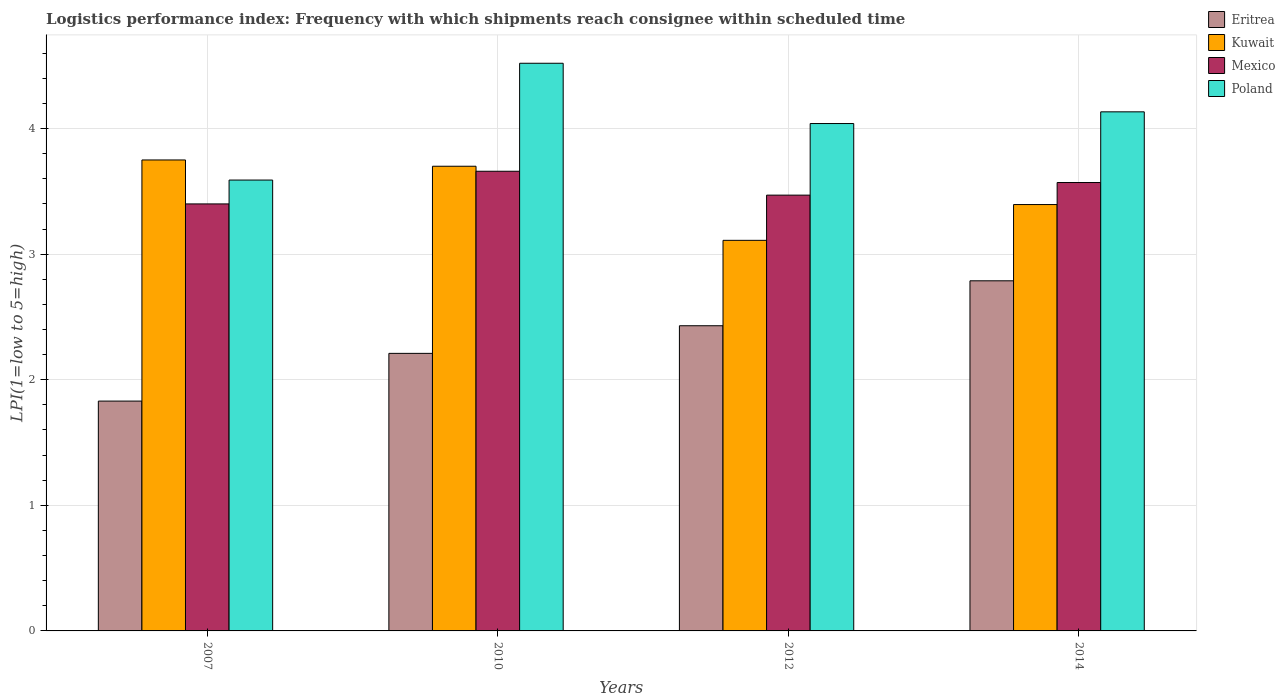Are the number of bars per tick equal to the number of legend labels?
Give a very brief answer. Yes. Are the number of bars on each tick of the X-axis equal?
Ensure brevity in your answer.  Yes. How many bars are there on the 1st tick from the right?
Offer a terse response. 4. What is the label of the 1st group of bars from the left?
Keep it short and to the point. 2007. What is the logistics performance index in Eritrea in 2014?
Your answer should be compact. 2.79. Across all years, what is the maximum logistics performance index in Eritrea?
Provide a short and direct response. 2.79. Across all years, what is the minimum logistics performance index in Kuwait?
Your response must be concise. 3.11. In which year was the logistics performance index in Poland maximum?
Your answer should be compact. 2010. In which year was the logistics performance index in Poland minimum?
Provide a succinct answer. 2007. What is the total logistics performance index in Eritrea in the graph?
Your answer should be very brief. 9.26. What is the difference between the logistics performance index in Eritrea in 2010 and that in 2012?
Ensure brevity in your answer.  -0.22. What is the difference between the logistics performance index in Mexico in 2010 and the logistics performance index in Eritrea in 2012?
Offer a terse response. 1.23. What is the average logistics performance index in Mexico per year?
Provide a short and direct response. 3.53. In the year 2007, what is the difference between the logistics performance index in Poland and logistics performance index in Kuwait?
Your answer should be very brief. -0.16. In how many years, is the logistics performance index in Poland greater than 2?
Offer a very short reply. 4. What is the ratio of the logistics performance index in Eritrea in 2007 to that in 2010?
Provide a succinct answer. 0.83. Is the logistics performance index in Kuwait in 2007 less than that in 2014?
Provide a short and direct response. No. Is the difference between the logistics performance index in Poland in 2007 and 2014 greater than the difference between the logistics performance index in Kuwait in 2007 and 2014?
Make the answer very short. No. What is the difference between the highest and the second highest logistics performance index in Poland?
Give a very brief answer. 0.39. What is the difference between the highest and the lowest logistics performance index in Kuwait?
Provide a succinct answer. 0.64. In how many years, is the logistics performance index in Eritrea greater than the average logistics performance index in Eritrea taken over all years?
Give a very brief answer. 2. Is the sum of the logistics performance index in Mexico in 2007 and 2014 greater than the maximum logistics performance index in Eritrea across all years?
Provide a short and direct response. Yes. Is it the case that in every year, the sum of the logistics performance index in Poland and logistics performance index in Eritrea is greater than the sum of logistics performance index in Mexico and logistics performance index in Kuwait?
Your answer should be very brief. No. What does the 4th bar from the right in 2012 represents?
Make the answer very short. Eritrea. How many bars are there?
Provide a short and direct response. 16. What is the difference between two consecutive major ticks on the Y-axis?
Keep it short and to the point. 1. Are the values on the major ticks of Y-axis written in scientific E-notation?
Give a very brief answer. No. Where does the legend appear in the graph?
Make the answer very short. Top right. How many legend labels are there?
Your answer should be compact. 4. What is the title of the graph?
Offer a terse response. Logistics performance index: Frequency with which shipments reach consignee within scheduled time. Does "Philippines" appear as one of the legend labels in the graph?
Ensure brevity in your answer.  No. What is the label or title of the X-axis?
Your response must be concise. Years. What is the label or title of the Y-axis?
Your answer should be compact. LPI(1=low to 5=high). What is the LPI(1=low to 5=high) of Eritrea in 2007?
Your answer should be compact. 1.83. What is the LPI(1=low to 5=high) in Kuwait in 2007?
Your answer should be very brief. 3.75. What is the LPI(1=low to 5=high) of Poland in 2007?
Your answer should be compact. 3.59. What is the LPI(1=low to 5=high) of Eritrea in 2010?
Your response must be concise. 2.21. What is the LPI(1=low to 5=high) in Mexico in 2010?
Provide a succinct answer. 3.66. What is the LPI(1=low to 5=high) of Poland in 2010?
Ensure brevity in your answer.  4.52. What is the LPI(1=low to 5=high) in Eritrea in 2012?
Make the answer very short. 2.43. What is the LPI(1=low to 5=high) of Kuwait in 2012?
Your answer should be very brief. 3.11. What is the LPI(1=low to 5=high) in Mexico in 2012?
Make the answer very short. 3.47. What is the LPI(1=low to 5=high) in Poland in 2012?
Offer a terse response. 4.04. What is the LPI(1=low to 5=high) in Eritrea in 2014?
Keep it short and to the point. 2.79. What is the LPI(1=low to 5=high) in Kuwait in 2014?
Keep it short and to the point. 3.39. What is the LPI(1=low to 5=high) in Mexico in 2014?
Offer a very short reply. 3.57. What is the LPI(1=low to 5=high) in Poland in 2014?
Your response must be concise. 4.13. Across all years, what is the maximum LPI(1=low to 5=high) of Eritrea?
Your answer should be compact. 2.79. Across all years, what is the maximum LPI(1=low to 5=high) of Kuwait?
Give a very brief answer. 3.75. Across all years, what is the maximum LPI(1=low to 5=high) in Mexico?
Offer a very short reply. 3.66. Across all years, what is the maximum LPI(1=low to 5=high) of Poland?
Provide a succinct answer. 4.52. Across all years, what is the minimum LPI(1=low to 5=high) in Eritrea?
Give a very brief answer. 1.83. Across all years, what is the minimum LPI(1=low to 5=high) in Kuwait?
Keep it short and to the point. 3.11. Across all years, what is the minimum LPI(1=low to 5=high) in Poland?
Offer a very short reply. 3.59. What is the total LPI(1=low to 5=high) in Eritrea in the graph?
Offer a very short reply. 9.26. What is the total LPI(1=low to 5=high) in Kuwait in the graph?
Give a very brief answer. 13.96. What is the total LPI(1=low to 5=high) in Mexico in the graph?
Ensure brevity in your answer.  14.1. What is the total LPI(1=low to 5=high) of Poland in the graph?
Provide a succinct answer. 16.28. What is the difference between the LPI(1=low to 5=high) of Eritrea in 2007 and that in 2010?
Provide a short and direct response. -0.38. What is the difference between the LPI(1=low to 5=high) in Kuwait in 2007 and that in 2010?
Your response must be concise. 0.05. What is the difference between the LPI(1=low to 5=high) of Mexico in 2007 and that in 2010?
Make the answer very short. -0.26. What is the difference between the LPI(1=low to 5=high) in Poland in 2007 and that in 2010?
Your response must be concise. -0.93. What is the difference between the LPI(1=low to 5=high) of Eritrea in 2007 and that in 2012?
Keep it short and to the point. -0.6. What is the difference between the LPI(1=low to 5=high) of Kuwait in 2007 and that in 2012?
Your response must be concise. 0.64. What is the difference between the LPI(1=low to 5=high) in Mexico in 2007 and that in 2012?
Make the answer very short. -0.07. What is the difference between the LPI(1=low to 5=high) in Poland in 2007 and that in 2012?
Ensure brevity in your answer.  -0.45. What is the difference between the LPI(1=low to 5=high) in Eritrea in 2007 and that in 2014?
Give a very brief answer. -0.96. What is the difference between the LPI(1=low to 5=high) of Kuwait in 2007 and that in 2014?
Your answer should be compact. 0.35. What is the difference between the LPI(1=low to 5=high) in Mexico in 2007 and that in 2014?
Provide a short and direct response. -0.17. What is the difference between the LPI(1=low to 5=high) of Poland in 2007 and that in 2014?
Your answer should be compact. -0.54. What is the difference between the LPI(1=low to 5=high) of Eritrea in 2010 and that in 2012?
Provide a succinct answer. -0.22. What is the difference between the LPI(1=low to 5=high) in Kuwait in 2010 and that in 2012?
Keep it short and to the point. 0.59. What is the difference between the LPI(1=low to 5=high) of Mexico in 2010 and that in 2012?
Offer a terse response. 0.19. What is the difference between the LPI(1=low to 5=high) in Poland in 2010 and that in 2012?
Ensure brevity in your answer.  0.48. What is the difference between the LPI(1=low to 5=high) in Eritrea in 2010 and that in 2014?
Provide a short and direct response. -0.58. What is the difference between the LPI(1=low to 5=high) in Kuwait in 2010 and that in 2014?
Offer a very short reply. 0.3. What is the difference between the LPI(1=low to 5=high) in Mexico in 2010 and that in 2014?
Offer a terse response. 0.09. What is the difference between the LPI(1=low to 5=high) in Poland in 2010 and that in 2014?
Provide a succinct answer. 0.39. What is the difference between the LPI(1=low to 5=high) of Eritrea in 2012 and that in 2014?
Your response must be concise. -0.36. What is the difference between the LPI(1=low to 5=high) in Kuwait in 2012 and that in 2014?
Keep it short and to the point. -0.28. What is the difference between the LPI(1=low to 5=high) of Mexico in 2012 and that in 2014?
Offer a very short reply. -0.1. What is the difference between the LPI(1=low to 5=high) of Poland in 2012 and that in 2014?
Give a very brief answer. -0.09. What is the difference between the LPI(1=low to 5=high) of Eritrea in 2007 and the LPI(1=low to 5=high) of Kuwait in 2010?
Your answer should be compact. -1.87. What is the difference between the LPI(1=low to 5=high) in Eritrea in 2007 and the LPI(1=low to 5=high) in Mexico in 2010?
Your answer should be very brief. -1.83. What is the difference between the LPI(1=low to 5=high) in Eritrea in 2007 and the LPI(1=low to 5=high) in Poland in 2010?
Give a very brief answer. -2.69. What is the difference between the LPI(1=low to 5=high) of Kuwait in 2007 and the LPI(1=low to 5=high) of Mexico in 2010?
Your answer should be compact. 0.09. What is the difference between the LPI(1=low to 5=high) in Kuwait in 2007 and the LPI(1=low to 5=high) in Poland in 2010?
Your answer should be compact. -0.77. What is the difference between the LPI(1=low to 5=high) of Mexico in 2007 and the LPI(1=low to 5=high) of Poland in 2010?
Provide a succinct answer. -1.12. What is the difference between the LPI(1=low to 5=high) in Eritrea in 2007 and the LPI(1=low to 5=high) in Kuwait in 2012?
Your answer should be compact. -1.28. What is the difference between the LPI(1=low to 5=high) of Eritrea in 2007 and the LPI(1=low to 5=high) of Mexico in 2012?
Offer a terse response. -1.64. What is the difference between the LPI(1=low to 5=high) of Eritrea in 2007 and the LPI(1=low to 5=high) of Poland in 2012?
Offer a terse response. -2.21. What is the difference between the LPI(1=low to 5=high) of Kuwait in 2007 and the LPI(1=low to 5=high) of Mexico in 2012?
Offer a very short reply. 0.28. What is the difference between the LPI(1=low to 5=high) in Kuwait in 2007 and the LPI(1=low to 5=high) in Poland in 2012?
Offer a very short reply. -0.29. What is the difference between the LPI(1=low to 5=high) in Mexico in 2007 and the LPI(1=low to 5=high) in Poland in 2012?
Keep it short and to the point. -0.64. What is the difference between the LPI(1=low to 5=high) of Eritrea in 2007 and the LPI(1=low to 5=high) of Kuwait in 2014?
Offer a terse response. -1.56. What is the difference between the LPI(1=low to 5=high) of Eritrea in 2007 and the LPI(1=low to 5=high) of Mexico in 2014?
Your answer should be very brief. -1.74. What is the difference between the LPI(1=low to 5=high) of Eritrea in 2007 and the LPI(1=low to 5=high) of Poland in 2014?
Provide a short and direct response. -2.3. What is the difference between the LPI(1=low to 5=high) in Kuwait in 2007 and the LPI(1=low to 5=high) in Mexico in 2014?
Provide a succinct answer. 0.18. What is the difference between the LPI(1=low to 5=high) in Kuwait in 2007 and the LPI(1=low to 5=high) in Poland in 2014?
Keep it short and to the point. -0.38. What is the difference between the LPI(1=low to 5=high) of Mexico in 2007 and the LPI(1=low to 5=high) of Poland in 2014?
Offer a terse response. -0.73. What is the difference between the LPI(1=low to 5=high) in Eritrea in 2010 and the LPI(1=low to 5=high) in Kuwait in 2012?
Ensure brevity in your answer.  -0.9. What is the difference between the LPI(1=low to 5=high) of Eritrea in 2010 and the LPI(1=low to 5=high) of Mexico in 2012?
Ensure brevity in your answer.  -1.26. What is the difference between the LPI(1=low to 5=high) in Eritrea in 2010 and the LPI(1=low to 5=high) in Poland in 2012?
Offer a very short reply. -1.83. What is the difference between the LPI(1=low to 5=high) of Kuwait in 2010 and the LPI(1=low to 5=high) of Mexico in 2012?
Make the answer very short. 0.23. What is the difference between the LPI(1=low to 5=high) of Kuwait in 2010 and the LPI(1=low to 5=high) of Poland in 2012?
Your answer should be very brief. -0.34. What is the difference between the LPI(1=low to 5=high) of Mexico in 2010 and the LPI(1=low to 5=high) of Poland in 2012?
Ensure brevity in your answer.  -0.38. What is the difference between the LPI(1=low to 5=high) in Eritrea in 2010 and the LPI(1=low to 5=high) in Kuwait in 2014?
Your answer should be very brief. -1.19. What is the difference between the LPI(1=low to 5=high) of Eritrea in 2010 and the LPI(1=low to 5=high) of Mexico in 2014?
Offer a terse response. -1.36. What is the difference between the LPI(1=low to 5=high) in Eritrea in 2010 and the LPI(1=low to 5=high) in Poland in 2014?
Ensure brevity in your answer.  -1.92. What is the difference between the LPI(1=low to 5=high) of Kuwait in 2010 and the LPI(1=low to 5=high) of Mexico in 2014?
Your answer should be very brief. 0.13. What is the difference between the LPI(1=low to 5=high) of Kuwait in 2010 and the LPI(1=low to 5=high) of Poland in 2014?
Provide a short and direct response. -0.43. What is the difference between the LPI(1=low to 5=high) in Mexico in 2010 and the LPI(1=low to 5=high) in Poland in 2014?
Offer a terse response. -0.47. What is the difference between the LPI(1=low to 5=high) in Eritrea in 2012 and the LPI(1=low to 5=high) in Kuwait in 2014?
Your answer should be very brief. -0.96. What is the difference between the LPI(1=low to 5=high) in Eritrea in 2012 and the LPI(1=low to 5=high) in Mexico in 2014?
Make the answer very short. -1.14. What is the difference between the LPI(1=low to 5=high) in Eritrea in 2012 and the LPI(1=low to 5=high) in Poland in 2014?
Give a very brief answer. -1.7. What is the difference between the LPI(1=low to 5=high) of Kuwait in 2012 and the LPI(1=low to 5=high) of Mexico in 2014?
Keep it short and to the point. -0.46. What is the difference between the LPI(1=low to 5=high) of Kuwait in 2012 and the LPI(1=low to 5=high) of Poland in 2014?
Provide a short and direct response. -1.02. What is the difference between the LPI(1=low to 5=high) of Mexico in 2012 and the LPI(1=low to 5=high) of Poland in 2014?
Make the answer very short. -0.66. What is the average LPI(1=low to 5=high) of Eritrea per year?
Give a very brief answer. 2.31. What is the average LPI(1=low to 5=high) of Kuwait per year?
Give a very brief answer. 3.49. What is the average LPI(1=low to 5=high) in Mexico per year?
Your response must be concise. 3.53. What is the average LPI(1=low to 5=high) of Poland per year?
Give a very brief answer. 4.07. In the year 2007, what is the difference between the LPI(1=low to 5=high) in Eritrea and LPI(1=low to 5=high) in Kuwait?
Your response must be concise. -1.92. In the year 2007, what is the difference between the LPI(1=low to 5=high) in Eritrea and LPI(1=low to 5=high) in Mexico?
Provide a succinct answer. -1.57. In the year 2007, what is the difference between the LPI(1=low to 5=high) of Eritrea and LPI(1=low to 5=high) of Poland?
Make the answer very short. -1.76. In the year 2007, what is the difference between the LPI(1=low to 5=high) in Kuwait and LPI(1=low to 5=high) in Mexico?
Provide a succinct answer. 0.35. In the year 2007, what is the difference between the LPI(1=low to 5=high) of Kuwait and LPI(1=low to 5=high) of Poland?
Offer a terse response. 0.16. In the year 2007, what is the difference between the LPI(1=low to 5=high) of Mexico and LPI(1=low to 5=high) of Poland?
Offer a terse response. -0.19. In the year 2010, what is the difference between the LPI(1=low to 5=high) of Eritrea and LPI(1=low to 5=high) of Kuwait?
Your response must be concise. -1.49. In the year 2010, what is the difference between the LPI(1=low to 5=high) in Eritrea and LPI(1=low to 5=high) in Mexico?
Keep it short and to the point. -1.45. In the year 2010, what is the difference between the LPI(1=low to 5=high) in Eritrea and LPI(1=low to 5=high) in Poland?
Your answer should be very brief. -2.31. In the year 2010, what is the difference between the LPI(1=low to 5=high) of Kuwait and LPI(1=low to 5=high) of Poland?
Your answer should be very brief. -0.82. In the year 2010, what is the difference between the LPI(1=low to 5=high) of Mexico and LPI(1=low to 5=high) of Poland?
Make the answer very short. -0.86. In the year 2012, what is the difference between the LPI(1=low to 5=high) in Eritrea and LPI(1=low to 5=high) in Kuwait?
Make the answer very short. -0.68. In the year 2012, what is the difference between the LPI(1=low to 5=high) in Eritrea and LPI(1=low to 5=high) in Mexico?
Offer a very short reply. -1.04. In the year 2012, what is the difference between the LPI(1=low to 5=high) in Eritrea and LPI(1=low to 5=high) in Poland?
Your answer should be compact. -1.61. In the year 2012, what is the difference between the LPI(1=low to 5=high) of Kuwait and LPI(1=low to 5=high) of Mexico?
Your answer should be very brief. -0.36. In the year 2012, what is the difference between the LPI(1=low to 5=high) in Kuwait and LPI(1=low to 5=high) in Poland?
Your answer should be very brief. -0.93. In the year 2012, what is the difference between the LPI(1=low to 5=high) of Mexico and LPI(1=low to 5=high) of Poland?
Keep it short and to the point. -0.57. In the year 2014, what is the difference between the LPI(1=low to 5=high) in Eritrea and LPI(1=low to 5=high) in Kuwait?
Make the answer very short. -0.61. In the year 2014, what is the difference between the LPI(1=low to 5=high) of Eritrea and LPI(1=low to 5=high) of Mexico?
Offer a very short reply. -0.78. In the year 2014, what is the difference between the LPI(1=low to 5=high) of Eritrea and LPI(1=low to 5=high) of Poland?
Your answer should be compact. -1.35. In the year 2014, what is the difference between the LPI(1=low to 5=high) in Kuwait and LPI(1=low to 5=high) in Mexico?
Give a very brief answer. -0.18. In the year 2014, what is the difference between the LPI(1=low to 5=high) of Kuwait and LPI(1=low to 5=high) of Poland?
Ensure brevity in your answer.  -0.74. In the year 2014, what is the difference between the LPI(1=low to 5=high) of Mexico and LPI(1=low to 5=high) of Poland?
Your answer should be compact. -0.56. What is the ratio of the LPI(1=low to 5=high) in Eritrea in 2007 to that in 2010?
Offer a very short reply. 0.83. What is the ratio of the LPI(1=low to 5=high) in Kuwait in 2007 to that in 2010?
Make the answer very short. 1.01. What is the ratio of the LPI(1=low to 5=high) of Mexico in 2007 to that in 2010?
Give a very brief answer. 0.93. What is the ratio of the LPI(1=low to 5=high) in Poland in 2007 to that in 2010?
Your answer should be compact. 0.79. What is the ratio of the LPI(1=low to 5=high) of Eritrea in 2007 to that in 2012?
Provide a succinct answer. 0.75. What is the ratio of the LPI(1=low to 5=high) of Kuwait in 2007 to that in 2012?
Offer a very short reply. 1.21. What is the ratio of the LPI(1=low to 5=high) of Mexico in 2007 to that in 2012?
Provide a short and direct response. 0.98. What is the ratio of the LPI(1=low to 5=high) in Poland in 2007 to that in 2012?
Provide a short and direct response. 0.89. What is the ratio of the LPI(1=low to 5=high) in Eritrea in 2007 to that in 2014?
Provide a short and direct response. 0.66. What is the ratio of the LPI(1=low to 5=high) in Kuwait in 2007 to that in 2014?
Ensure brevity in your answer.  1.1. What is the ratio of the LPI(1=low to 5=high) of Mexico in 2007 to that in 2014?
Keep it short and to the point. 0.95. What is the ratio of the LPI(1=low to 5=high) in Poland in 2007 to that in 2014?
Keep it short and to the point. 0.87. What is the ratio of the LPI(1=low to 5=high) in Eritrea in 2010 to that in 2012?
Offer a terse response. 0.91. What is the ratio of the LPI(1=low to 5=high) in Kuwait in 2010 to that in 2012?
Make the answer very short. 1.19. What is the ratio of the LPI(1=low to 5=high) in Mexico in 2010 to that in 2012?
Keep it short and to the point. 1.05. What is the ratio of the LPI(1=low to 5=high) in Poland in 2010 to that in 2012?
Offer a very short reply. 1.12. What is the ratio of the LPI(1=low to 5=high) in Eritrea in 2010 to that in 2014?
Your response must be concise. 0.79. What is the ratio of the LPI(1=low to 5=high) in Kuwait in 2010 to that in 2014?
Give a very brief answer. 1.09. What is the ratio of the LPI(1=low to 5=high) of Mexico in 2010 to that in 2014?
Your answer should be compact. 1.03. What is the ratio of the LPI(1=low to 5=high) in Poland in 2010 to that in 2014?
Offer a terse response. 1.09. What is the ratio of the LPI(1=low to 5=high) of Eritrea in 2012 to that in 2014?
Offer a terse response. 0.87. What is the ratio of the LPI(1=low to 5=high) in Kuwait in 2012 to that in 2014?
Provide a succinct answer. 0.92. What is the ratio of the LPI(1=low to 5=high) in Mexico in 2012 to that in 2014?
Give a very brief answer. 0.97. What is the ratio of the LPI(1=low to 5=high) in Poland in 2012 to that in 2014?
Keep it short and to the point. 0.98. What is the difference between the highest and the second highest LPI(1=low to 5=high) in Eritrea?
Your answer should be compact. 0.36. What is the difference between the highest and the second highest LPI(1=low to 5=high) of Kuwait?
Your answer should be very brief. 0.05. What is the difference between the highest and the second highest LPI(1=low to 5=high) in Mexico?
Offer a very short reply. 0.09. What is the difference between the highest and the second highest LPI(1=low to 5=high) in Poland?
Ensure brevity in your answer.  0.39. What is the difference between the highest and the lowest LPI(1=low to 5=high) of Eritrea?
Make the answer very short. 0.96. What is the difference between the highest and the lowest LPI(1=low to 5=high) of Kuwait?
Your response must be concise. 0.64. What is the difference between the highest and the lowest LPI(1=low to 5=high) of Mexico?
Your response must be concise. 0.26. What is the difference between the highest and the lowest LPI(1=low to 5=high) in Poland?
Your answer should be very brief. 0.93. 